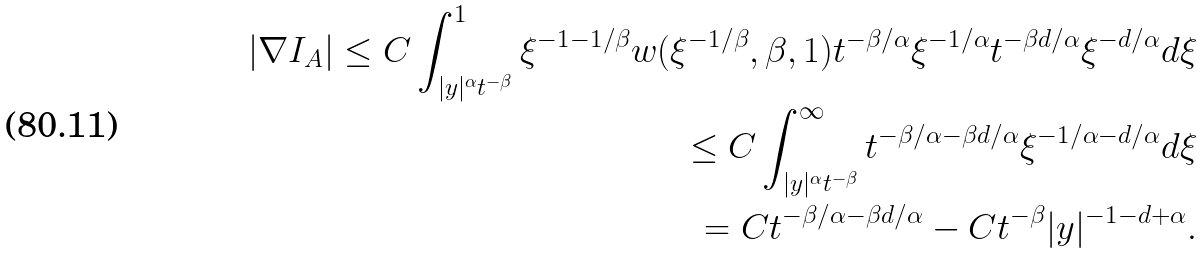<formula> <loc_0><loc_0><loc_500><loc_500>\left | \nabla I _ { A } \right | \leq C \int _ { | y | ^ { \alpha } t ^ { - \beta } } ^ { 1 } \xi ^ { - 1 - 1 / \beta } w ( \xi ^ { - 1 / \beta } , \beta , 1 ) t ^ { - \beta / \alpha } \xi ^ { - 1 / \alpha } t ^ { - \beta d / \alpha } \xi ^ { - d / \alpha } d \xi \\ \leq C \int _ { | y | ^ { \alpha } t ^ { - \beta } } ^ { \infty } t ^ { - \beta / \alpha - \beta d / \alpha } \xi ^ { - 1 / \alpha - d / \alpha } d \xi \\ = C t ^ { - \beta / \alpha - \beta d / \alpha } - C t ^ { - \beta } | y | ^ { - 1 - d + \alpha } .</formula> 